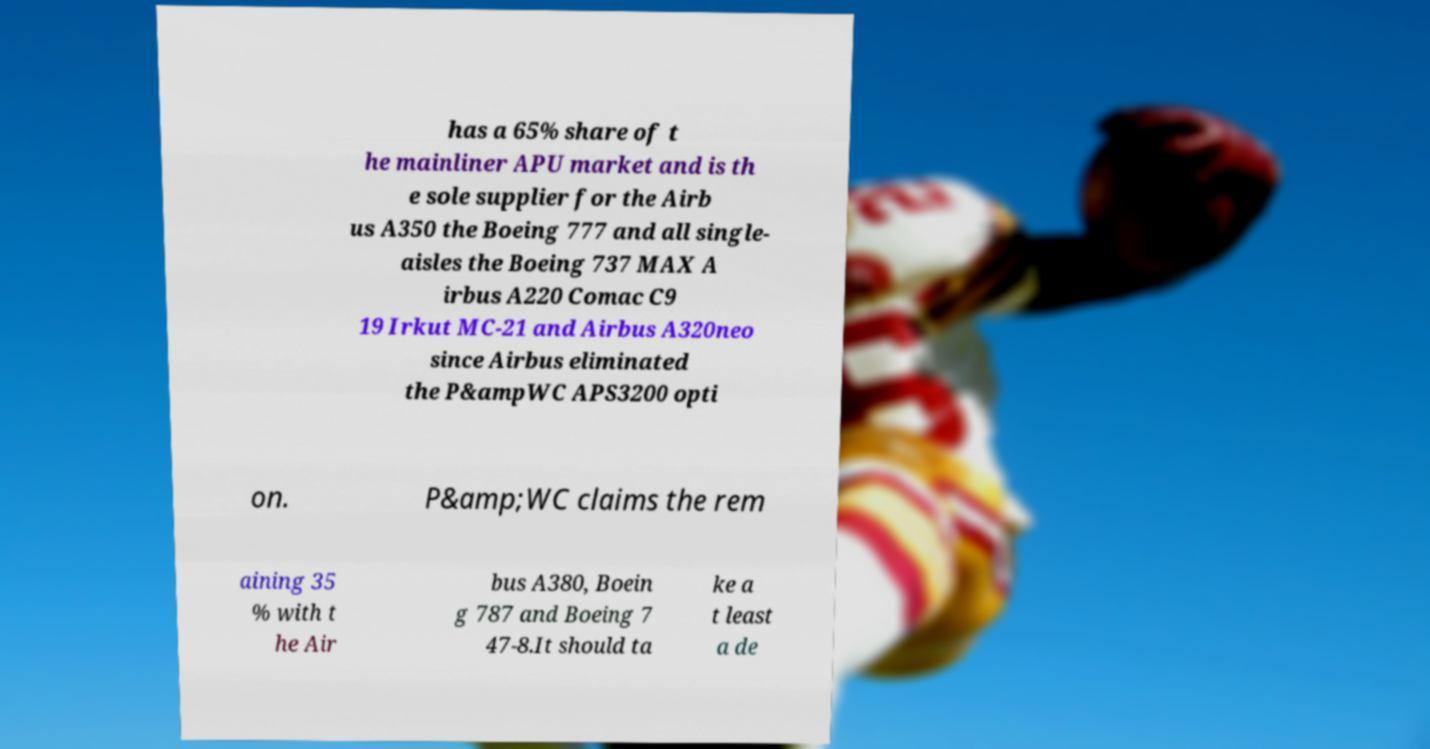For documentation purposes, I need the text within this image transcribed. Could you provide that? has a 65% share of t he mainliner APU market and is th e sole supplier for the Airb us A350 the Boeing 777 and all single- aisles the Boeing 737 MAX A irbus A220 Comac C9 19 Irkut MC-21 and Airbus A320neo since Airbus eliminated the P&ampWC APS3200 opti on. P&amp;WC claims the rem aining 35 % with t he Air bus A380, Boein g 787 and Boeing 7 47-8.It should ta ke a t least a de 